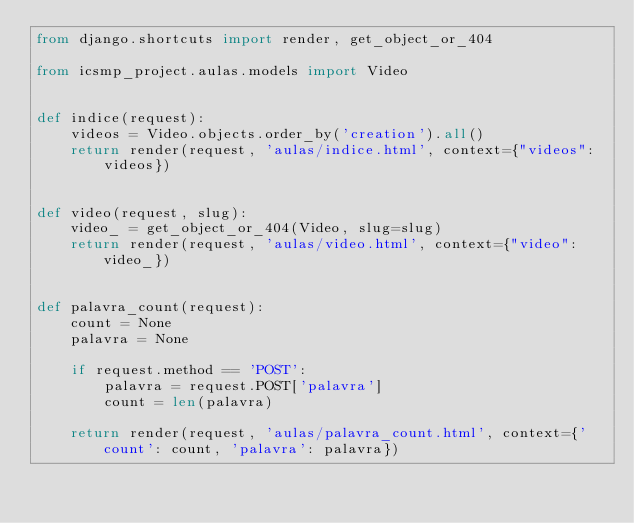<code> <loc_0><loc_0><loc_500><loc_500><_Python_>from django.shortcuts import render, get_object_or_404

from icsmp_project.aulas.models import Video


def indice(request):
    videos = Video.objects.order_by('creation').all()
    return render(request, 'aulas/indice.html', context={"videos": videos})


def video(request, slug):
    video_ = get_object_or_404(Video, slug=slug)
    return render(request, 'aulas/video.html', context={"video": video_})


def palavra_count(request):
    count = None
    palavra = None

    if request.method == 'POST':
        palavra = request.POST['palavra']
        count = len(palavra)

    return render(request, 'aulas/palavra_count.html', context={'count': count, 'palavra': palavra})
</code> 